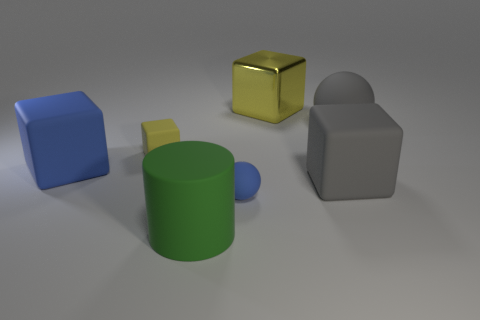Subtract 1 blocks. How many blocks are left? 3 Add 3 matte balls. How many objects exist? 10 Subtract all cubes. How many objects are left? 3 Add 2 tiny blue matte things. How many tiny blue matte things are left? 3 Add 4 large yellow blocks. How many large yellow blocks exist? 5 Subtract 0 green blocks. How many objects are left? 7 Subtract all large gray metallic cylinders. Subtract all yellow things. How many objects are left? 5 